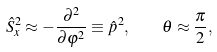Convert formula to latex. <formula><loc_0><loc_0><loc_500><loc_500>\hat { S } _ { x } ^ { 2 } \approx - \frac { \partial ^ { 2 } } { \partial \varphi ^ { 2 } } \equiv \hat { p } ^ { 2 } , \quad \theta \approx \frac { \pi } { 2 } ,</formula> 